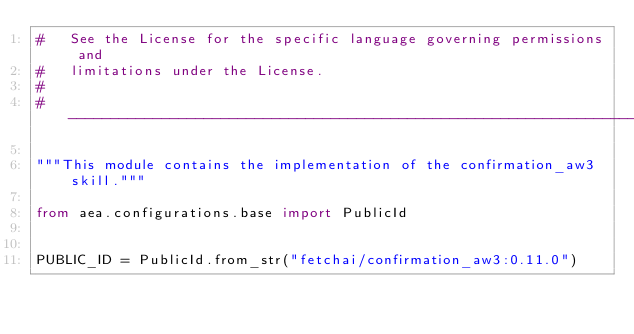<code> <loc_0><loc_0><loc_500><loc_500><_Python_>#   See the License for the specific language governing permissions and
#   limitations under the License.
#
# ------------------------------------------------------------------------------

"""This module contains the implementation of the confirmation_aw3 skill."""

from aea.configurations.base import PublicId


PUBLIC_ID = PublicId.from_str("fetchai/confirmation_aw3:0.11.0")
</code> 